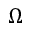<formula> <loc_0><loc_0><loc_500><loc_500>\Omega</formula> 